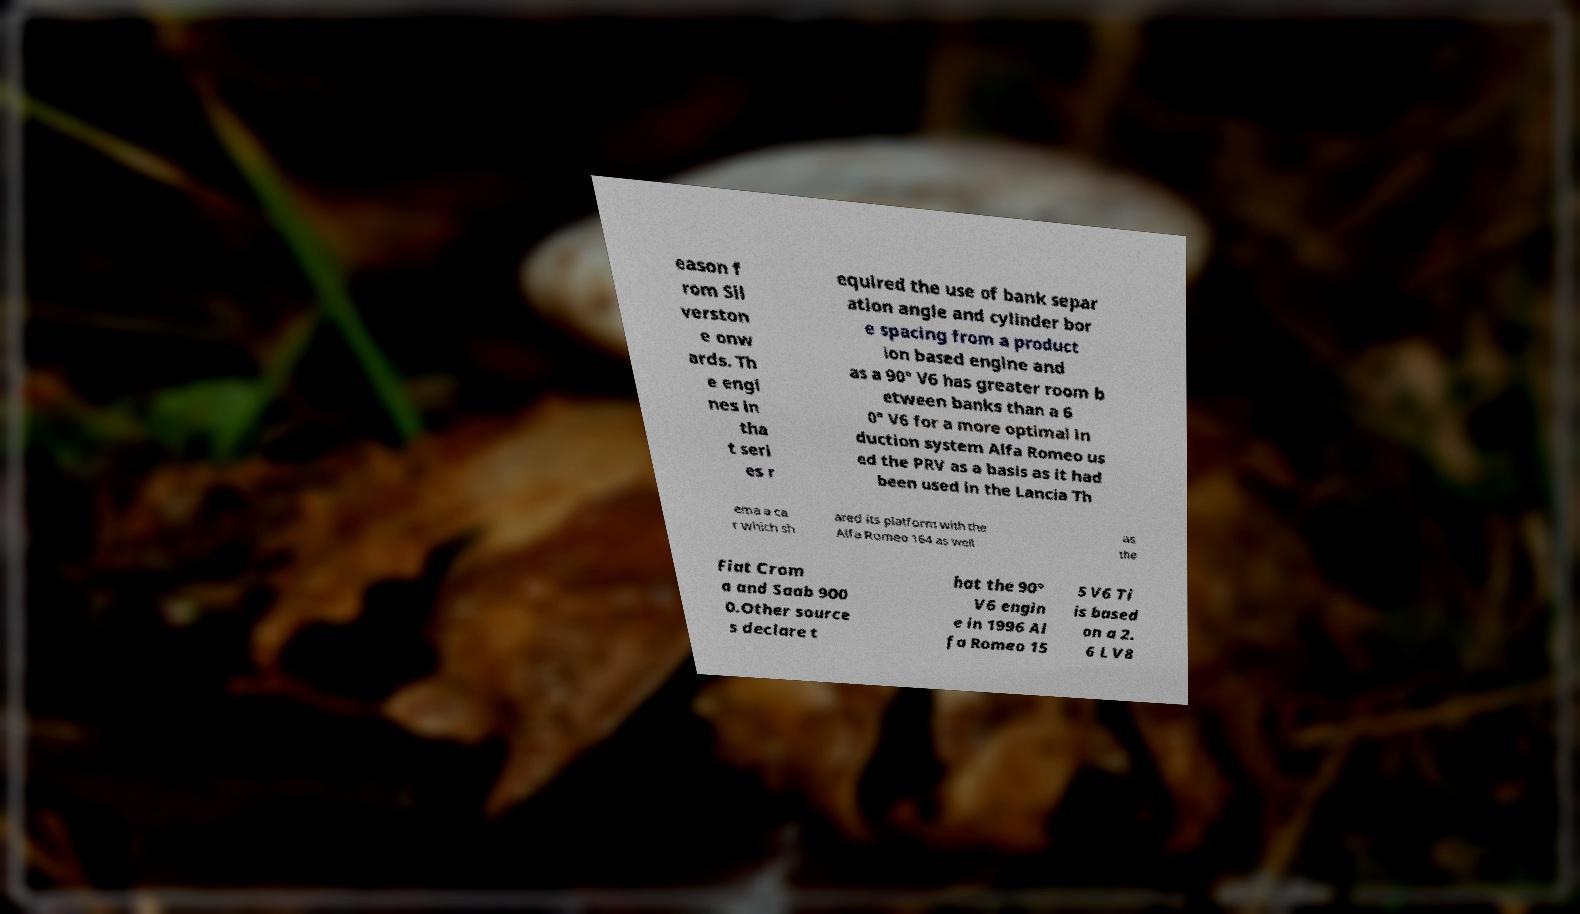Could you assist in decoding the text presented in this image and type it out clearly? eason f rom Sil verston e onw ards. Th e engi nes in tha t seri es r equired the use of bank separ ation angle and cylinder bor e spacing from a product ion based engine and as a 90° V6 has greater room b etween banks than a 6 0° V6 for a more optimal in duction system Alfa Romeo us ed the PRV as a basis as it had been used in the Lancia Th ema a ca r which sh ared its platform with the Alfa Romeo 164 as well as the Fiat Crom a and Saab 900 0.Other source s declare t hat the 90° V6 engin e in 1996 Al fa Romeo 15 5 V6 Ti is based on a 2. 6 L V8 